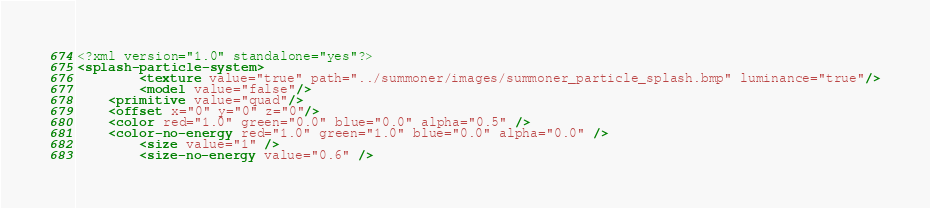<code> <loc_0><loc_0><loc_500><loc_500><_XML_><?xml version="1.0" standalone="yes"?>
<splash-particle-system>
    	<texture value="true" path="../summoner/images/summoner_particle_splash.bmp" luminance="true"/>
        <model value="false"/>
	<primitive value="quad"/>
	<offset x="0" y="0" z="0"/>
	<color red="1.0" green="0.0" blue="0.0" alpha="0.5" />
	<color-no-energy red="1.0" green="1.0" blue="0.0" alpha="0.0" />
    	<size value="1" />
    	<size-no-energy value="0.6" /></code> 